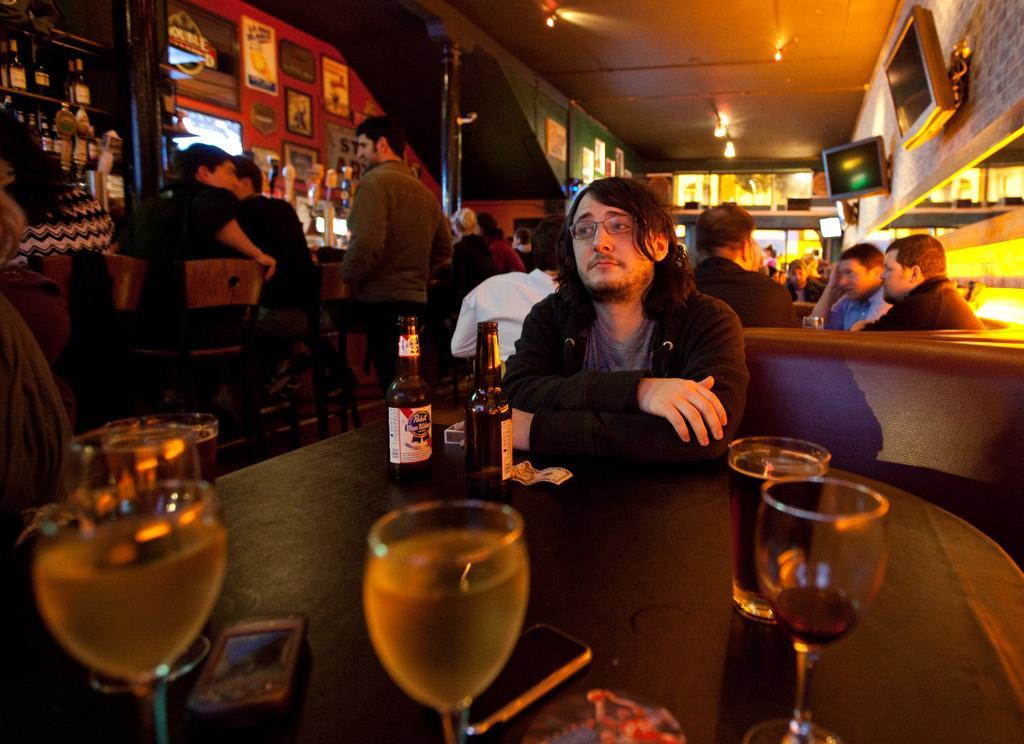Can you describe this image briefly? In this image there are a group of persons sitting, there is a man standing, there are chairs, there is a table towards the bottom of the image, there are objects on the table, there is a shelf towards the left of the image, there are objects in the shelf, there is a wall, there are objects on the wall, there are televisions on the wall, there is roof towards the top of the image, there are lights. 